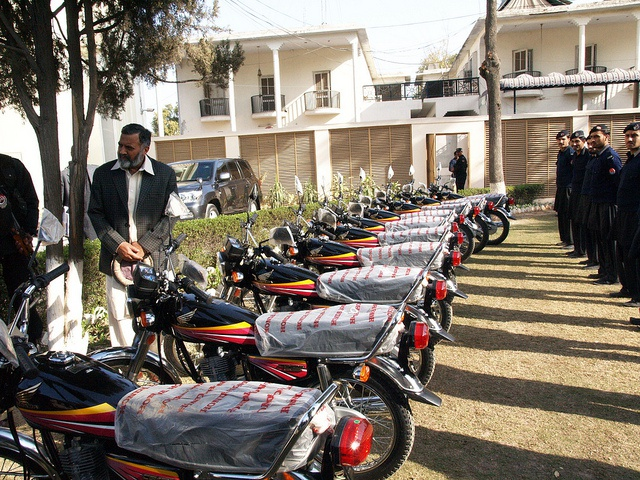Describe the objects in this image and their specific colors. I can see motorcycle in black, gray, darkgray, and lightgray tones, motorcycle in black, gray, lightgray, and darkgray tones, motorcycle in black, gray, lightgray, and darkgray tones, people in black, gray, white, and darkgray tones, and motorcycle in black, lightgray, darkgray, and gray tones in this image. 